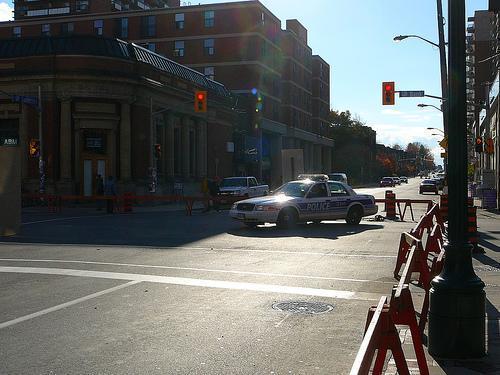How many police cars are there?
Give a very brief answer. 1. 